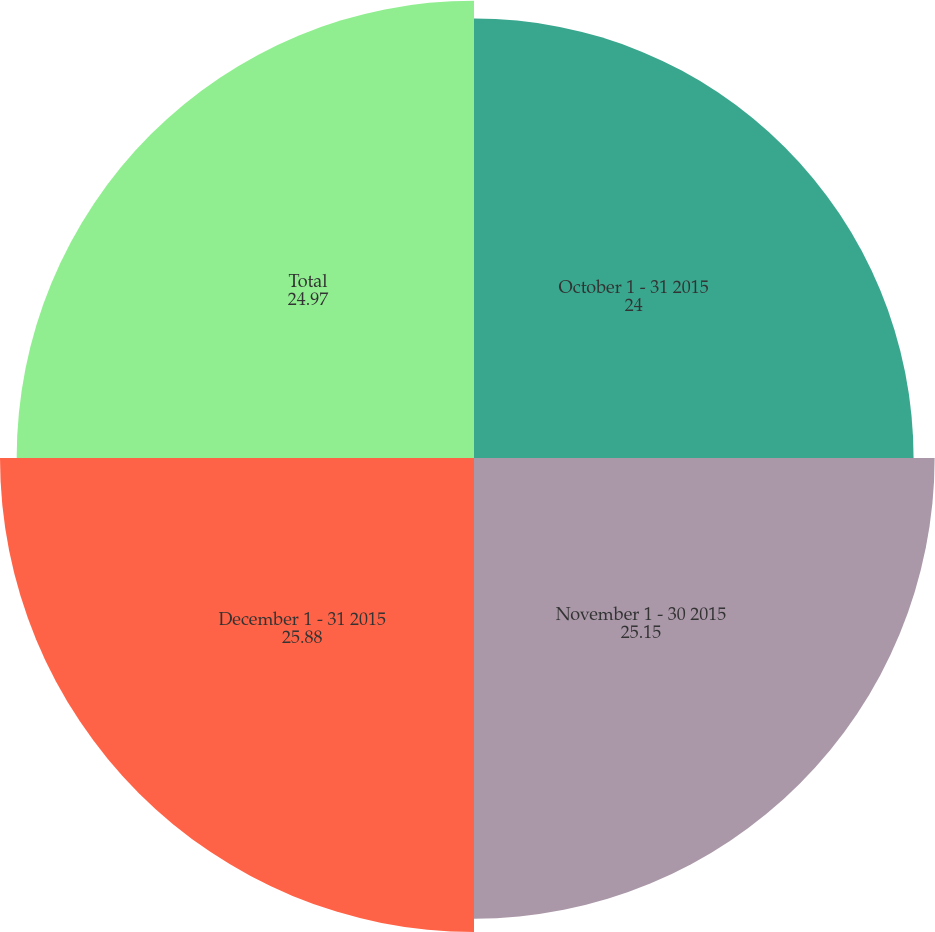Convert chart to OTSL. <chart><loc_0><loc_0><loc_500><loc_500><pie_chart><fcel>October 1 - 31 2015<fcel>November 1 - 30 2015<fcel>December 1 - 31 2015<fcel>Total<nl><fcel>24.0%<fcel>25.15%<fcel>25.88%<fcel>24.97%<nl></chart> 